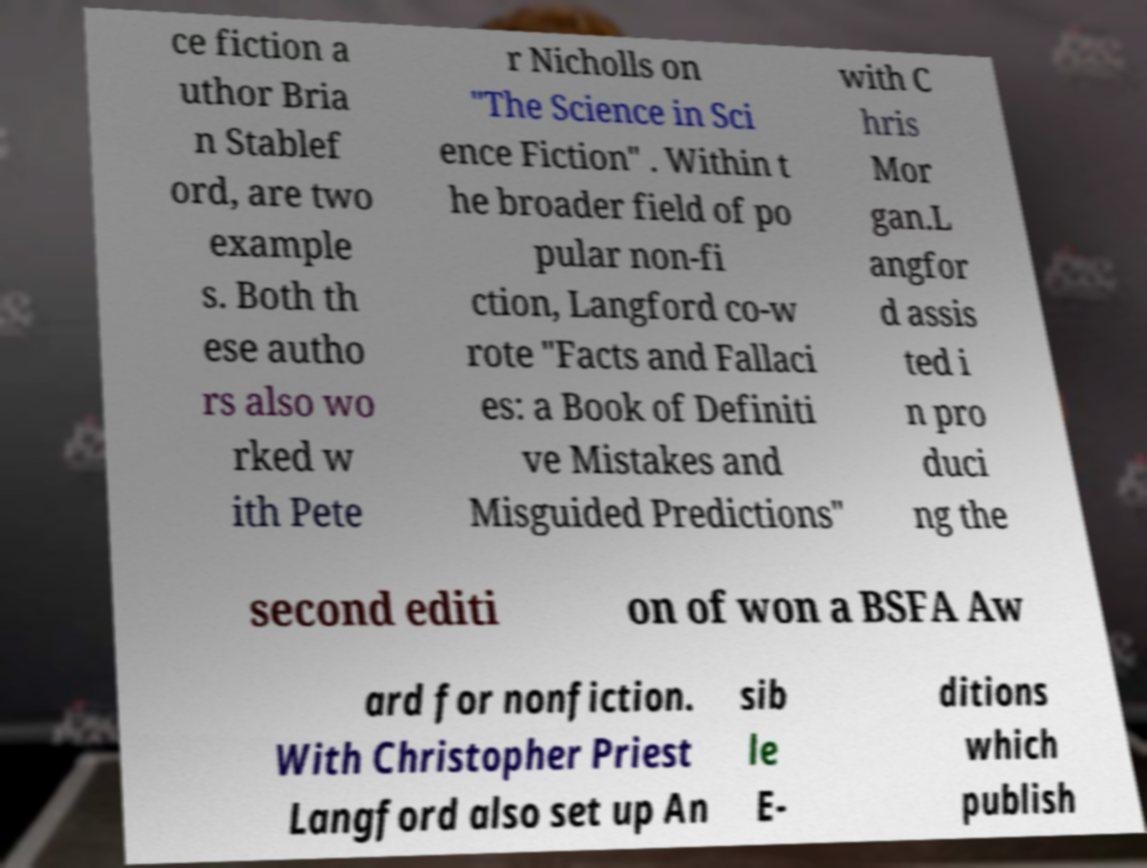There's text embedded in this image that I need extracted. Can you transcribe it verbatim? ce fiction a uthor Bria n Stablef ord, are two example s. Both th ese autho rs also wo rked w ith Pete r Nicholls on "The Science in Sci ence Fiction" . Within t he broader field of po pular non-fi ction, Langford co-w rote "Facts and Fallaci es: a Book of Definiti ve Mistakes and Misguided Predictions" with C hris Mor gan.L angfor d assis ted i n pro duci ng the second editi on of won a BSFA Aw ard for nonfiction. With Christopher Priest Langford also set up An sib le E- ditions which publish 